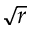Convert formula to latex. <formula><loc_0><loc_0><loc_500><loc_500>\sqrt { r }</formula> 